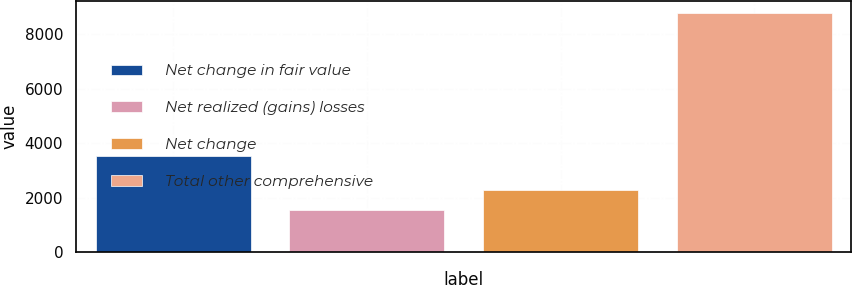Convert chart. <chart><loc_0><loc_0><loc_500><loc_500><bar_chart><fcel>Net change in fair value<fcel>Net realized (gains) losses<fcel>Net change<fcel>Total other comprehensive<nl><fcel>3541<fcel>1557<fcel>2278.2<fcel>8769<nl></chart> 